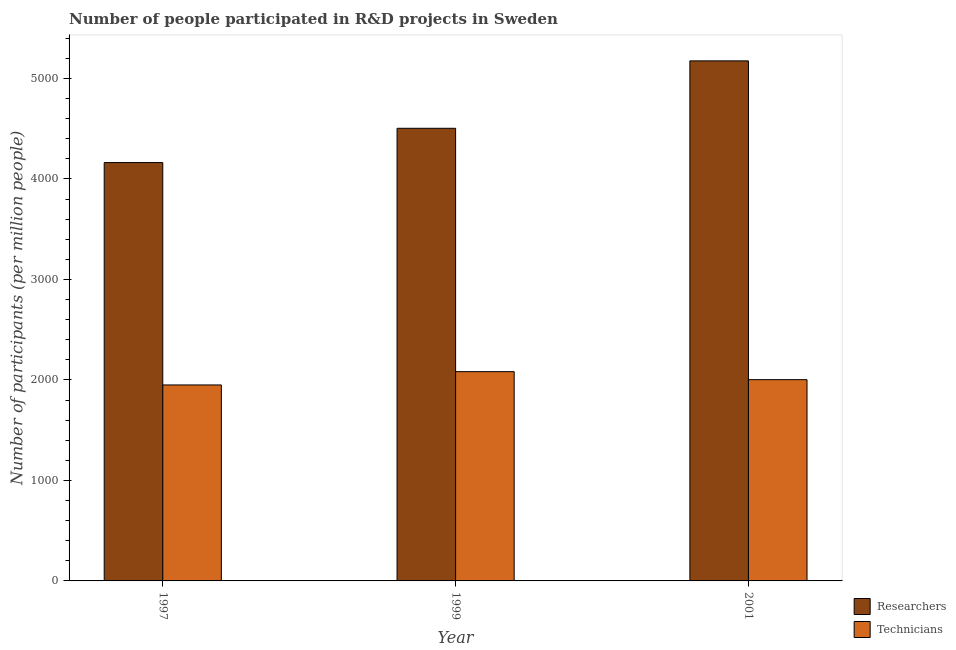How many different coloured bars are there?
Ensure brevity in your answer.  2. How many bars are there on the 2nd tick from the right?
Your response must be concise. 2. What is the label of the 2nd group of bars from the left?
Ensure brevity in your answer.  1999. What is the number of technicians in 2001?
Ensure brevity in your answer.  2002.57. Across all years, what is the maximum number of technicians?
Your answer should be compact. 2082.24. Across all years, what is the minimum number of researchers?
Ensure brevity in your answer.  4162.72. In which year was the number of technicians minimum?
Your response must be concise. 1997. What is the total number of technicians in the graph?
Make the answer very short. 6034.81. What is the difference between the number of researchers in 1997 and that in 1999?
Provide a short and direct response. -341.18. What is the difference between the number of technicians in 1997 and the number of researchers in 1999?
Keep it short and to the point. -132.24. What is the average number of researchers per year?
Give a very brief answer. 4613.74. In the year 1999, what is the difference between the number of technicians and number of researchers?
Offer a very short reply. 0. What is the ratio of the number of researchers in 1997 to that in 2001?
Provide a succinct answer. 0.8. Is the number of researchers in 1997 less than that in 1999?
Your response must be concise. Yes. Is the difference between the number of researchers in 1999 and 2001 greater than the difference between the number of technicians in 1999 and 2001?
Your answer should be very brief. No. What is the difference between the highest and the second highest number of researchers?
Offer a terse response. 670.7. What is the difference between the highest and the lowest number of technicians?
Offer a very short reply. 132.24. Is the sum of the number of researchers in 1997 and 1999 greater than the maximum number of technicians across all years?
Provide a short and direct response. Yes. What does the 1st bar from the left in 1997 represents?
Provide a short and direct response. Researchers. What does the 1st bar from the right in 2001 represents?
Provide a succinct answer. Technicians. Are all the bars in the graph horizontal?
Give a very brief answer. No. What is the difference between two consecutive major ticks on the Y-axis?
Make the answer very short. 1000. Are the values on the major ticks of Y-axis written in scientific E-notation?
Provide a succinct answer. No. Does the graph contain any zero values?
Make the answer very short. No. Does the graph contain grids?
Provide a short and direct response. No. Where does the legend appear in the graph?
Keep it short and to the point. Bottom right. What is the title of the graph?
Your answer should be very brief. Number of people participated in R&D projects in Sweden. What is the label or title of the Y-axis?
Your answer should be very brief. Number of participants (per million people). What is the Number of participants (per million people) of Researchers in 1997?
Offer a terse response. 4162.72. What is the Number of participants (per million people) of Technicians in 1997?
Provide a succinct answer. 1950. What is the Number of participants (per million people) of Researchers in 1999?
Your answer should be compact. 4503.9. What is the Number of participants (per million people) of Technicians in 1999?
Your response must be concise. 2082.24. What is the Number of participants (per million people) in Researchers in 2001?
Keep it short and to the point. 5174.6. What is the Number of participants (per million people) of Technicians in 2001?
Your answer should be very brief. 2002.57. Across all years, what is the maximum Number of participants (per million people) of Researchers?
Keep it short and to the point. 5174.6. Across all years, what is the maximum Number of participants (per million people) of Technicians?
Your answer should be compact. 2082.24. Across all years, what is the minimum Number of participants (per million people) in Researchers?
Your answer should be very brief. 4162.72. Across all years, what is the minimum Number of participants (per million people) in Technicians?
Offer a very short reply. 1950. What is the total Number of participants (per million people) in Researchers in the graph?
Your response must be concise. 1.38e+04. What is the total Number of participants (per million people) in Technicians in the graph?
Provide a succinct answer. 6034.81. What is the difference between the Number of participants (per million people) in Researchers in 1997 and that in 1999?
Your response must be concise. -341.18. What is the difference between the Number of participants (per million people) of Technicians in 1997 and that in 1999?
Ensure brevity in your answer.  -132.24. What is the difference between the Number of participants (per million people) of Researchers in 1997 and that in 2001?
Your response must be concise. -1011.88. What is the difference between the Number of participants (per million people) in Technicians in 1997 and that in 2001?
Ensure brevity in your answer.  -52.56. What is the difference between the Number of participants (per million people) in Researchers in 1999 and that in 2001?
Your answer should be very brief. -670.7. What is the difference between the Number of participants (per million people) in Technicians in 1999 and that in 2001?
Offer a terse response. 79.67. What is the difference between the Number of participants (per million people) in Researchers in 1997 and the Number of participants (per million people) in Technicians in 1999?
Your answer should be very brief. 2080.48. What is the difference between the Number of participants (per million people) of Researchers in 1997 and the Number of participants (per million people) of Technicians in 2001?
Your response must be concise. 2160.15. What is the difference between the Number of participants (per million people) of Researchers in 1999 and the Number of participants (per million people) of Technicians in 2001?
Ensure brevity in your answer.  2501.34. What is the average Number of participants (per million people) of Researchers per year?
Keep it short and to the point. 4613.74. What is the average Number of participants (per million people) in Technicians per year?
Your response must be concise. 2011.6. In the year 1997, what is the difference between the Number of participants (per million people) of Researchers and Number of participants (per million people) of Technicians?
Make the answer very short. 2212.72. In the year 1999, what is the difference between the Number of participants (per million people) in Researchers and Number of participants (per million people) in Technicians?
Give a very brief answer. 2421.66. In the year 2001, what is the difference between the Number of participants (per million people) of Researchers and Number of participants (per million people) of Technicians?
Make the answer very short. 3172.04. What is the ratio of the Number of participants (per million people) in Researchers in 1997 to that in 1999?
Make the answer very short. 0.92. What is the ratio of the Number of participants (per million people) of Technicians in 1997 to that in 1999?
Keep it short and to the point. 0.94. What is the ratio of the Number of participants (per million people) of Researchers in 1997 to that in 2001?
Provide a succinct answer. 0.8. What is the ratio of the Number of participants (per million people) in Technicians in 1997 to that in 2001?
Your answer should be compact. 0.97. What is the ratio of the Number of participants (per million people) of Researchers in 1999 to that in 2001?
Provide a succinct answer. 0.87. What is the ratio of the Number of participants (per million people) of Technicians in 1999 to that in 2001?
Give a very brief answer. 1.04. What is the difference between the highest and the second highest Number of participants (per million people) in Researchers?
Your response must be concise. 670.7. What is the difference between the highest and the second highest Number of participants (per million people) in Technicians?
Provide a short and direct response. 79.67. What is the difference between the highest and the lowest Number of participants (per million people) of Researchers?
Provide a succinct answer. 1011.88. What is the difference between the highest and the lowest Number of participants (per million people) of Technicians?
Keep it short and to the point. 132.24. 